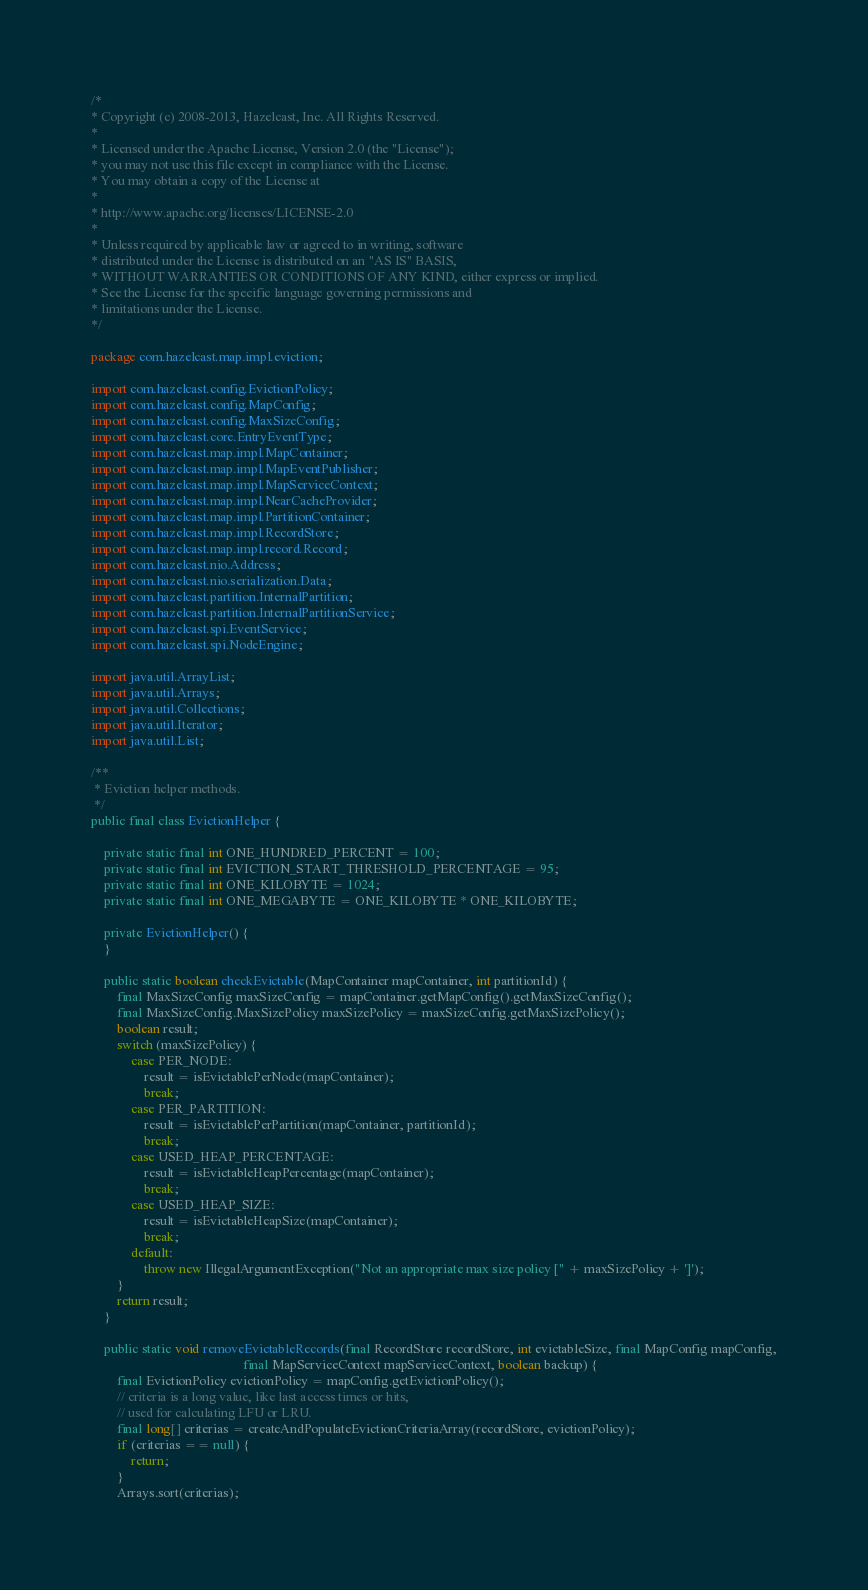<code> <loc_0><loc_0><loc_500><loc_500><_Java_>/*
* Copyright (c) 2008-2013, Hazelcast, Inc. All Rights Reserved.
*
* Licensed under the Apache License, Version 2.0 (the "License");
* you may not use this file except in compliance with the License.
* You may obtain a copy of the License at
*
* http://www.apache.org/licenses/LICENSE-2.0
*
* Unless required by applicable law or agreed to in writing, software
* distributed under the License is distributed on an "AS IS" BASIS,
* WITHOUT WARRANTIES OR CONDITIONS OF ANY KIND, either express or implied.
* See the License for the specific language governing permissions and
* limitations under the License.
*/

package com.hazelcast.map.impl.eviction;

import com.hazelcast.config.EvictionPolicy;
import com.hazelcast.config.MapConfig;
import com.hazelcast.config.MaxSizeConfig;
import com.hazelcast.core.EntryEventType;
import com.hazelcast.map.impl.MapContainer;
import com.hazelcast.map.impl.MapEventPublisher;
import com.hazelcast.map.impl.MapServiceContext;
import com.hazelcast.map.impl.NearCacheProvider;
import com.hazelcast.map.impl.PartitionContainer;
import com.hazelcast.map.impl.RecordStore;
import com.hazelcast.map.impl.record.Record;
import com.hazelcast.nio.Address;
import com.hazelcast.nio.serialization.Data;
import com.hazelcast.partition.InternalPartition;
import com.hazelcast.partition.InternalPartitionService;
import com.hazelcast.spi.EventService;
import com.hazelcast.spi.NodeEngine;

import java.util.ArrayList;
import java.util.Arrays;
import java.util.Collections;
import java.util.Iterator;
import java.util.List;

/**
 * Eviction helper methods.
 */
public final class EvictionHelper {

    private static final int ONE_HUNDRED_PERCENT = 100;
    private static final int EVICTION_START_THRESHOLD_PERCENTAGE = 95;
    private static final int ONE_KILOBYTE = 1024;
    private static final int ONE_MEGABYTE = ONE_KILOBYTE * ONE_KILOBYTE;

    private EvictionHelper() {
    }

    public static boolean checkEvictable(MapContainer mapContainer, int partitionId) {
        final MaxSizeConfig maxSizeConfig = mapContainer.getMapConfig().getMaxSizeConfig();
        final MaxSizeConfig.MaxSizePolicy maxSizePolicy = maxSizeConfig.getMaxSizePolicy();
        boolean result;
        switch (maxSizePolicy) {
            case PER_NODE:
                result = isEvictablePerNode(mapContainer);
                break;
            case PER_PARTITION:
                result = isEvictablePerPartition(mapContainer, partitionId);
                break;
            case USED_HEAP_PERCENTAGE:
                result = isEvictableHeapPercentage(mapContainer);
                break;
            case USED_HEAP_SIZE:
                result = isEvictableHeapSize(mapContainer);
                break;
            default:
                throw new IllegalArgumentException("Not an appropriate max size policy [" + maxSizePolicy + ']');
        }
        return result;
    }

    public static void removeEvictableRecords(final RecordStore recordStore, int evictableSize, final MapConfig mapConfig,
                                              final MapServiceContext mapServiceContext, boolean backup) {
        final EvictionPolicy evictionPolicy = mapConfig.getEvictionPolicy();
        // criteria is a long value, like last access times or hits,
        // used for calculating LFU or LRU.
        final long[] criterias = createAndPopulateEvictionCriteriaArray(recordStore, evictionPolicy);
        if (criterias == null) {
            return;
        }
        Arrays.sort(criterias);</code> 